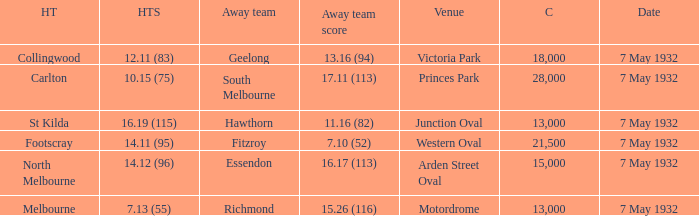What is the total of crowd with Home team score of 14.12 (96)? 15000.0. 